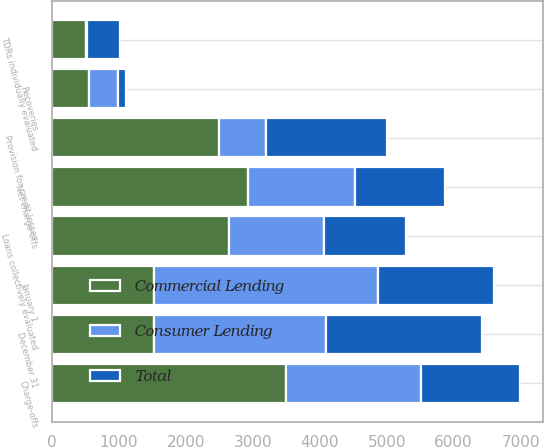Convert chart. <chart><loc_0><loc_0><loc_500><loc_500><stacked_bar_chart><ecel><fcel>January 1<fcel>Charge-offs<fcel>Recoveries<fcel>Net charge-offs<fcel>Provision for credit losses<fcel>December 31<fcel>TDRs individually evaluated<fcel>Loans collectively evaluated<nl><fcel>Consumer Lending<fcel>3345<fcel>2017<fcel>427<fcel>1590<fcel>704<fcel>2567<fcel>24<fcel>1419<nl><fcel>Total<fcel>1727<fcel>1475<fcel>129<fcel>1346<fcel>1798<fcel>2320<fcel>485<fcel>1227<nl><fcel>Commercial Lending<fcel>1532.5<fcel>3492<fcel>556<fcel>2936<fcel>2502<fcel>1532.5<fcel>509<fcel>2646<nl></chart> 